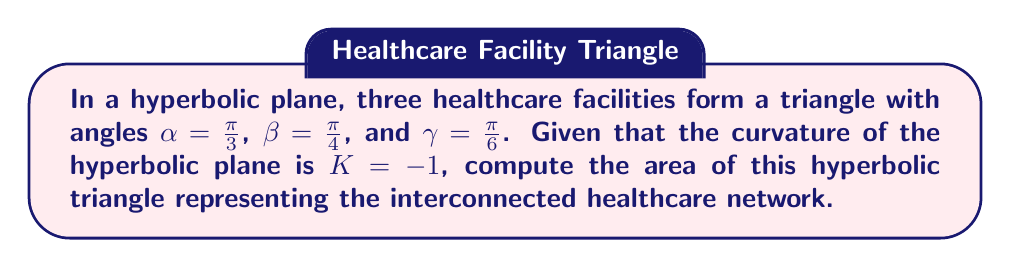Provide a solution to this math problem. To solve this problem, we'll use the Gauss-Bonnet formula for hyperbolic triangles:

$$A = \pi - (\alpha + \beta + \gamma)$$

Where $A$ is the area of the hyperbolic triangle and $\alpha$, $\beta$, and $\gamma$ are the angles of the triangle.

Step 1: Convert all angles to radians (they're already in radians in this case).

Step 2: Sum the angles:
$$\alpha + \beta + \gamma = \frac{\pi}{3} + \frac{\pi}{4} + \frac{\pi}{6}$$

Step 3: Simplify the sum:
$$\frac{\pi}{3} + \frac{\pi}{4} + \frac{\pi}{6} = \frac{4\pi}{12} + \frac{3\pi}{12} + \frac{2\pi}{12} = \frac{9\pi}{12} = \frac{3\pi}{4}$$

Step 4: Apply the Gauss-Bonnet formula:
$$A = \pi - \frac{3\pi}{4} = \frac{\pi}{4}$$

Step 5: Since the curvature $K = -1$, the area in standard units is simply $\frac{\pi}{4}$.

This area represents the optimal coverage of the healthcare network in the hyperbolic plane, which can be used to analyze resource allocation and patient access in this non-Euclidean space.
Answer: $\frac{\pi}{4}$ 